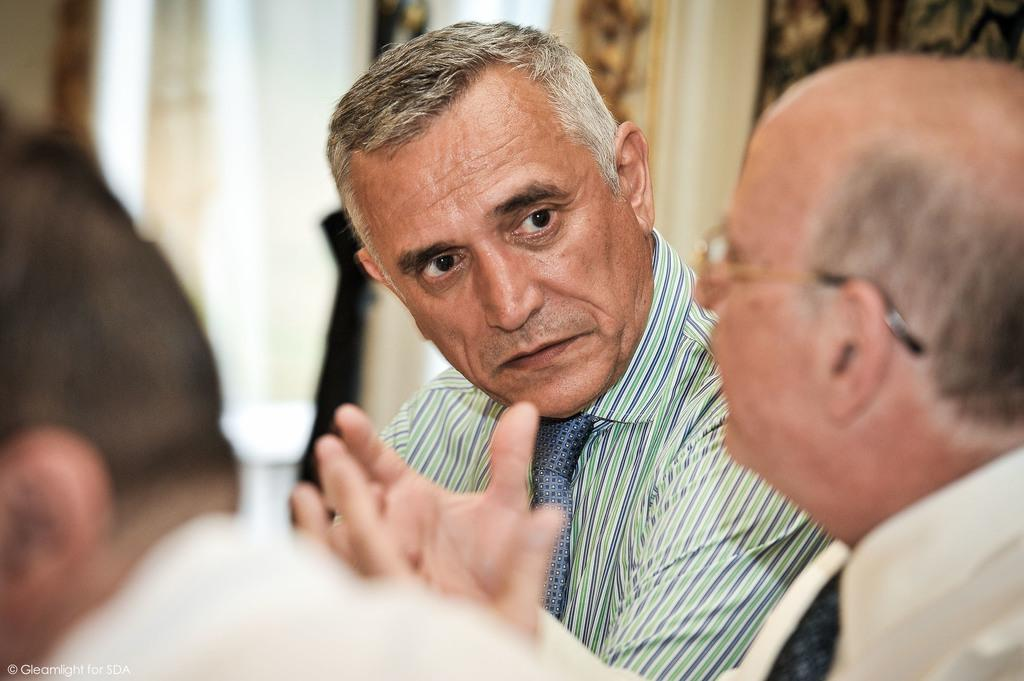How many people are in the image? There are three men in the image. What is the middle person doing? The middle person is speaking. Can you describe the background of the men? The background of the men is blurred. What type of bird can be seen attempting to wash the clothes in the image? There are no birds or clothes visible in the image, and therefore no such activity can be observed. 